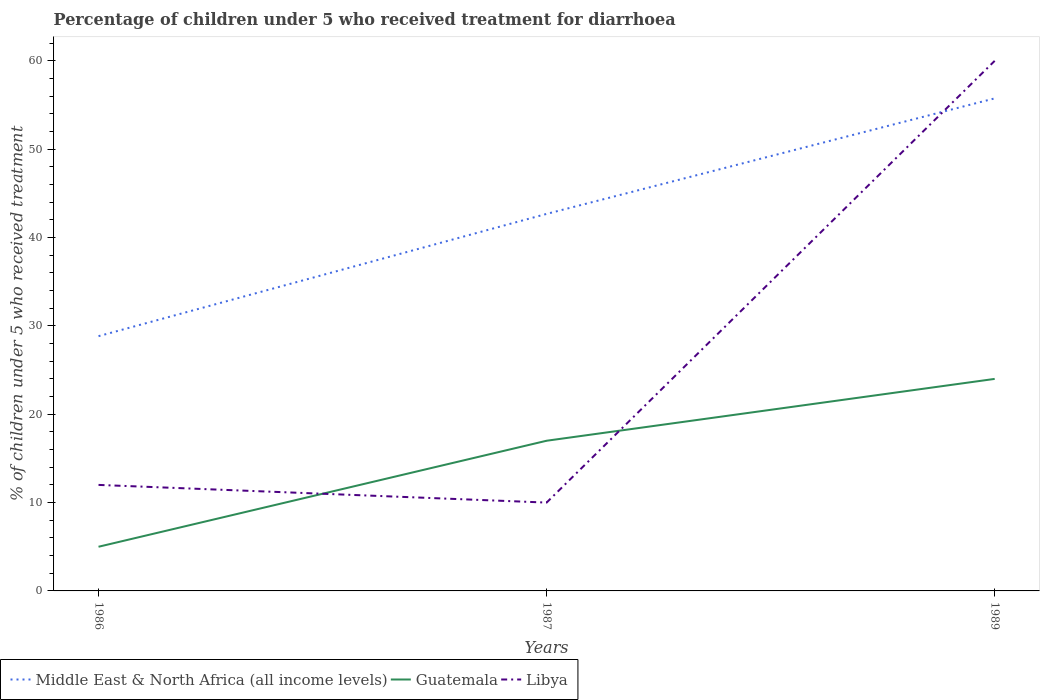How many different coloured lines are there?
Provide a short and direct response. 3. Does the line corresponding to Libya intersect with the line corresponding to Guatemala?
Your answer should be very brief. Yes. Is the number of lines equal to the number of legend labels?
Keep it short and to the point. Yes. Across all years, what is the maximum percentage of children who received treatment for diarrhoea  in Guatemala?
Give a very brief answer. 5. What is the difference between the highest and the second highest percentage of children who received treatment for diarrhoea  in Middle East & North Africa (all income levels)?
Offer a terse response. 26.92. Is the percentage of children who received treatment for diarrhoea  in Libya strictly greater than the percentage of children who received treatment for diarrhoea  in Middle East & North Africa (all income levels) over the years?
Offer a very short reply. No. How many lines are there?
Provide a succinct answer. 3. How many years are there in the graph?
Offer a terse response. 3. Does the graph contain any zero values?
Offer a very short reply. No. Where does the legend appear in the graph?
Ensure brevity in your answer.  Bottom left. What is the title of the graph?
Your answer should be very brief. Percentage of children under 5 who received treatment for diarrhoea. What is the label or title of the Y-axis?
Provide a succinct answer. % of children under 5 who received treatment. What is the % of children under 5 who received treatment of Middle East & North Africa (all income levels) in 1986?
Provide a short and direct response. 28.84. What is the % of children under 5 who received treatment of Middle East & North Africa (all income levels) in 1987?
Offer a terse response. 42.68. What is the % of children under 5 who received treatment in Middle East & North Africa (all income levels) in 1989?
Make the answer very short. 55.75. What is the % of children under 5 who received treatment in Guatemala in 1989?
Offer a terse response. 24. Across all years, what is the maximum % of children under 5 who received treatment in Middle East & North Africa (all income levels)?
Offer a terse response. 55.75. Across all years, what is the maximum % of children under 5 who received treatment in Guatemala?
Make the answer very short. 24. Across all years, what is the maximum % of children under 5 who received treatment of Libya?
Offer a very short reply. 60. Across all years, what is the minimum % of children under 5 who received treatment in Middle East & North Africa (all income levels)?
Give a very brief answer. 28.84. Across all years, what is the minimum % of children under 5 who received treatment in Guatemala?
Keep it short and to the point. 5. Across all years, what is the minimum % of children under 5 who received treatment in Libya?
Your answer should be very brief. 10. What is the total % of children under 5 who received treatment in Middle East & North Africa (all income levels) in the graph?
Provide a succinct answer. 127.27. What is the total % of children under 5 who received treatment in Guatemala in the graph?
Your response must be concise. 46. What is the difference between the % of children under 5 who received treatment in Middle East & North Africa (all income levels) in 1986 and that in 1987?
Your response must be concise. -13.84. What is the difference between the % of children under 5 who received treatment in Middle East & North Africa (all income levels) in 1986 and that in 1989?
Your answer should be compact. -26.92. What is the difference between the % of children under 5 who received treatment of Libya in 1986 and that in 1989?
Make the answer very short. -48. What is the difference between the % of children under 5 who received treatment in Middle East & North Africa (all income levels) in 1987 and that in 1989?
Your answer should be very brief. -13.07. What is the difference between the % of children under 5 who received treatment in Guatemala in 1987 and that in 1989?
Your answer should be very brief. -7. What is the difference between the % of children under 5 who received treatment of Middle East & North Africa (all income levels) in 1986 and the % of children under 5 who received treatment of Guatemala in 1987?
Your response must be concise. 11.84. What is the difference between the % of children under 5 who received treatment in Middle East & North Africa (all income levels) in 1986 and the % of children under 5 who received treatment in Libya in 1987?
Offer a terse response. 18.84. What is the difference between the % of children under 5 who received treatment of Guatemala in 1986 and the % of children under 5 who received treatment of Libya in 1987?
Your response must be concise. -5. What is the difference between the % of children under 5 who received treatment of Middle East & North Africa (all income levels) in 1986 and the % of children under 5 who received treatment of Guatemala in 1989?
Offer a terse response. 4.84. What is the difference between the % of children under 5 who received treatment of Middle East & North Africa (all income levels) in 1986 and the % of children under 5 who received treatment of Libya in 1989?
Offer a terse response. -31.16. What is the difference between the % of children under 5 who received treatment of Guatemala in 1986 and the % of children under 5 who received treatment of Libya in 1989?
Your answer should be compact. -55. What is the difference between the % of children under 5 who received treatment in Middle East & North Africa (all income levels) in 1987 and the % of children under 5 who received treatment in Guatemala in 1989?
Your answer should be very brief. 18.68. What is the difference between the % of children under 5 who received treatment of Middle East & North Africa (all income levels) in 1987 and the % of children under 5 who received treatment of Libya in 1989?
Your answer should be compact. -17.32. What is the difference between the % of children under 5 who received treatment of Guatemala in 1987 and the % of children under 5 who received treatment of Libya in 1989?
Your response must be concise. -43. What is the average % of children under 5 who received treatment of Middle East & North Africa (all income levels) per year?
Give a very brief answer. 42.42. What is the average % of children under 5 who received treatment in Guatemala per year?
Offer a very short reply. 15.33. What is the average % of children under 5 who received treatment in Libya per year?
Keep it short and to the point. 27.33. In the year 1986, what is the difference between the % of children under 5 who received treatment of Middle East & North Africa (all income levels) and % of children under 5 who received treatment of Guatemala?
Make the answer very short. 23.84. In the year 1986, what is the difference between the % of children under 5 who received treatment in Middle East & North Africa (all income levels) and % of children under 5 who received treatment in Libya?
Offer a very short reply. 16.84. In the year 1987, what is the difference between the % of children under 5 who received treatment of Middle East & North Africa (all income levels) and % of children under 5 who received treatment of Guatemala?
Provide a succinct answer. 25.68. In the year 1987, what is the difference between the % of children under 5 who received treatment in Middle East & North Africa (all income levels) and % of children under 5 who received treatment in Libya?
Offer a very short reply. 32.68. In the year 1989, what is the difference between the % of children under 5 who received treatment in Middle East & North Africa (all income levels) and % of children under 5 who received treatment in Guatemala?
Offer a terse response. 31.75. In the year 1989, what is the difference between the % of children under 5 who received treatment in Middle East & North Africa (all income levels) and % of children under 5 who received treatment in Libya?
Offer a very short reply. -4.25. In the year 1989, what is the difference between the % of children under 5 who received treatment in Guatemala and % of children under 5 who received treatment in Libya?
Keep it short and to the point. -36. What is the ratio of the % of children under 5 who received treatment in Middle East & North Africa (all income levels) in 1986 to that in 1987?
Your answer should be very brief. 0.68. What is the ratio of the % of children under 5 who received treatment in Guatemala in 1986 to that in 1987?
Give a very brief answer. 0.29. What is the ratio of the % of children under 5 who received treatment in Libya in 1986 to that in 1987?
Make the answer very short. 1.2. What is the ratio of the % of children under 5 who received treatment of Middle East & North Africa (all income levels) in 1986 to that in 1989?
Offer a terse response. 0.52. What is the ratio of the % of children under 5 who received treatment of Guatemala in 1986 to that in 1989?
Provide a succinct answer. 0.21. What is the ratio of the % of children under 5 who received treatment in Middle East & North Africa (all income levels) in 1987 to that in 1989?
Ensure brevity in your answer.  0.77. What is the ratio of the % of children under 5 who received treatment in Guatemala in 1987 to that in 1989?
Ensure brevity in your answer.  0.71. What is the difference between the highest and the second highest % of children under 5 who received treatment in Middle East & North Africa (all income levels)?
Your answer should be very brief. 13.07. What is the difference between the highest and the second highest % of children under 5 who received treatment in Libya?
Keep it short and to the point. 48. What is the difference between the highest and the lowest % of children under 5 who received treatment of Middle East & North Africa (all income levels)?
Your answer should be very brief. 26.92. What is the difference between the highest and the lowest % of children under 5 who received treatment of Guatemala?
Give a very brief answer. 19. What is the difference between the highest and the lowest % of children under 5 who received treatment in Libya?
Ensure brevity in your answer.  50. 